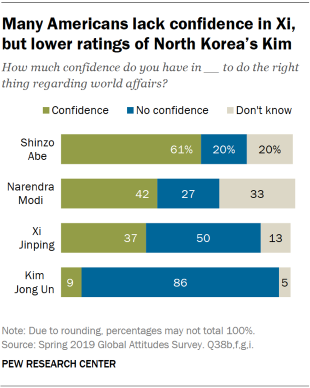Highlight a few significant elements in this photo. The value of the largest blue bar is not 50, it is actually less than that. The bar graph clearly indicates that the American people have the highest level of confidence in Shinzo Abe as a leader. 